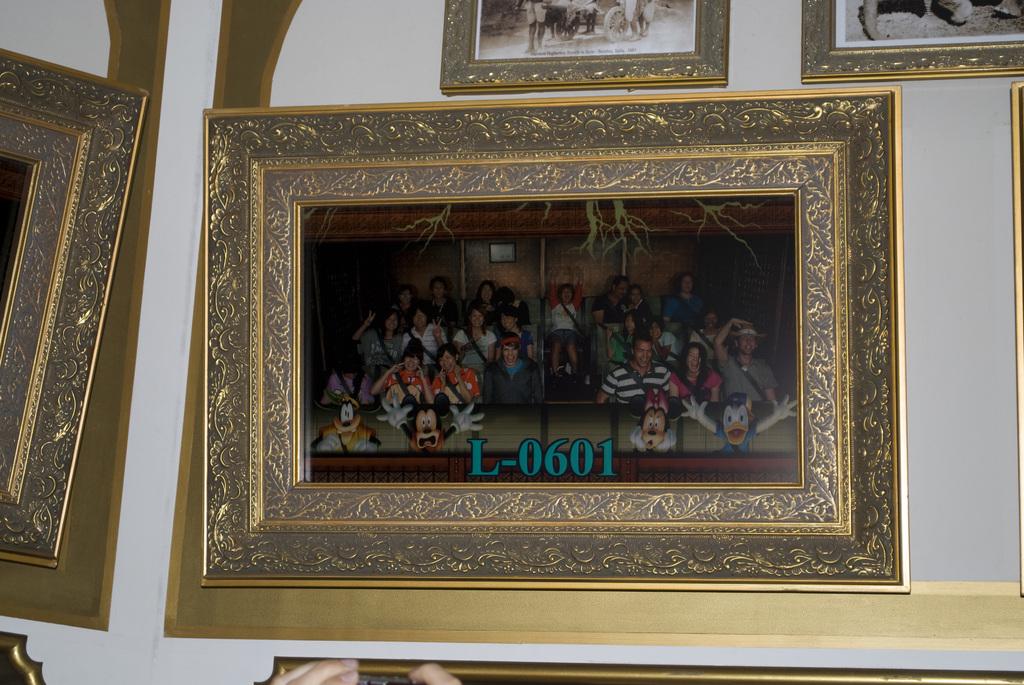What is the identification number of the art print?
Offer a terse response. L-0601. 